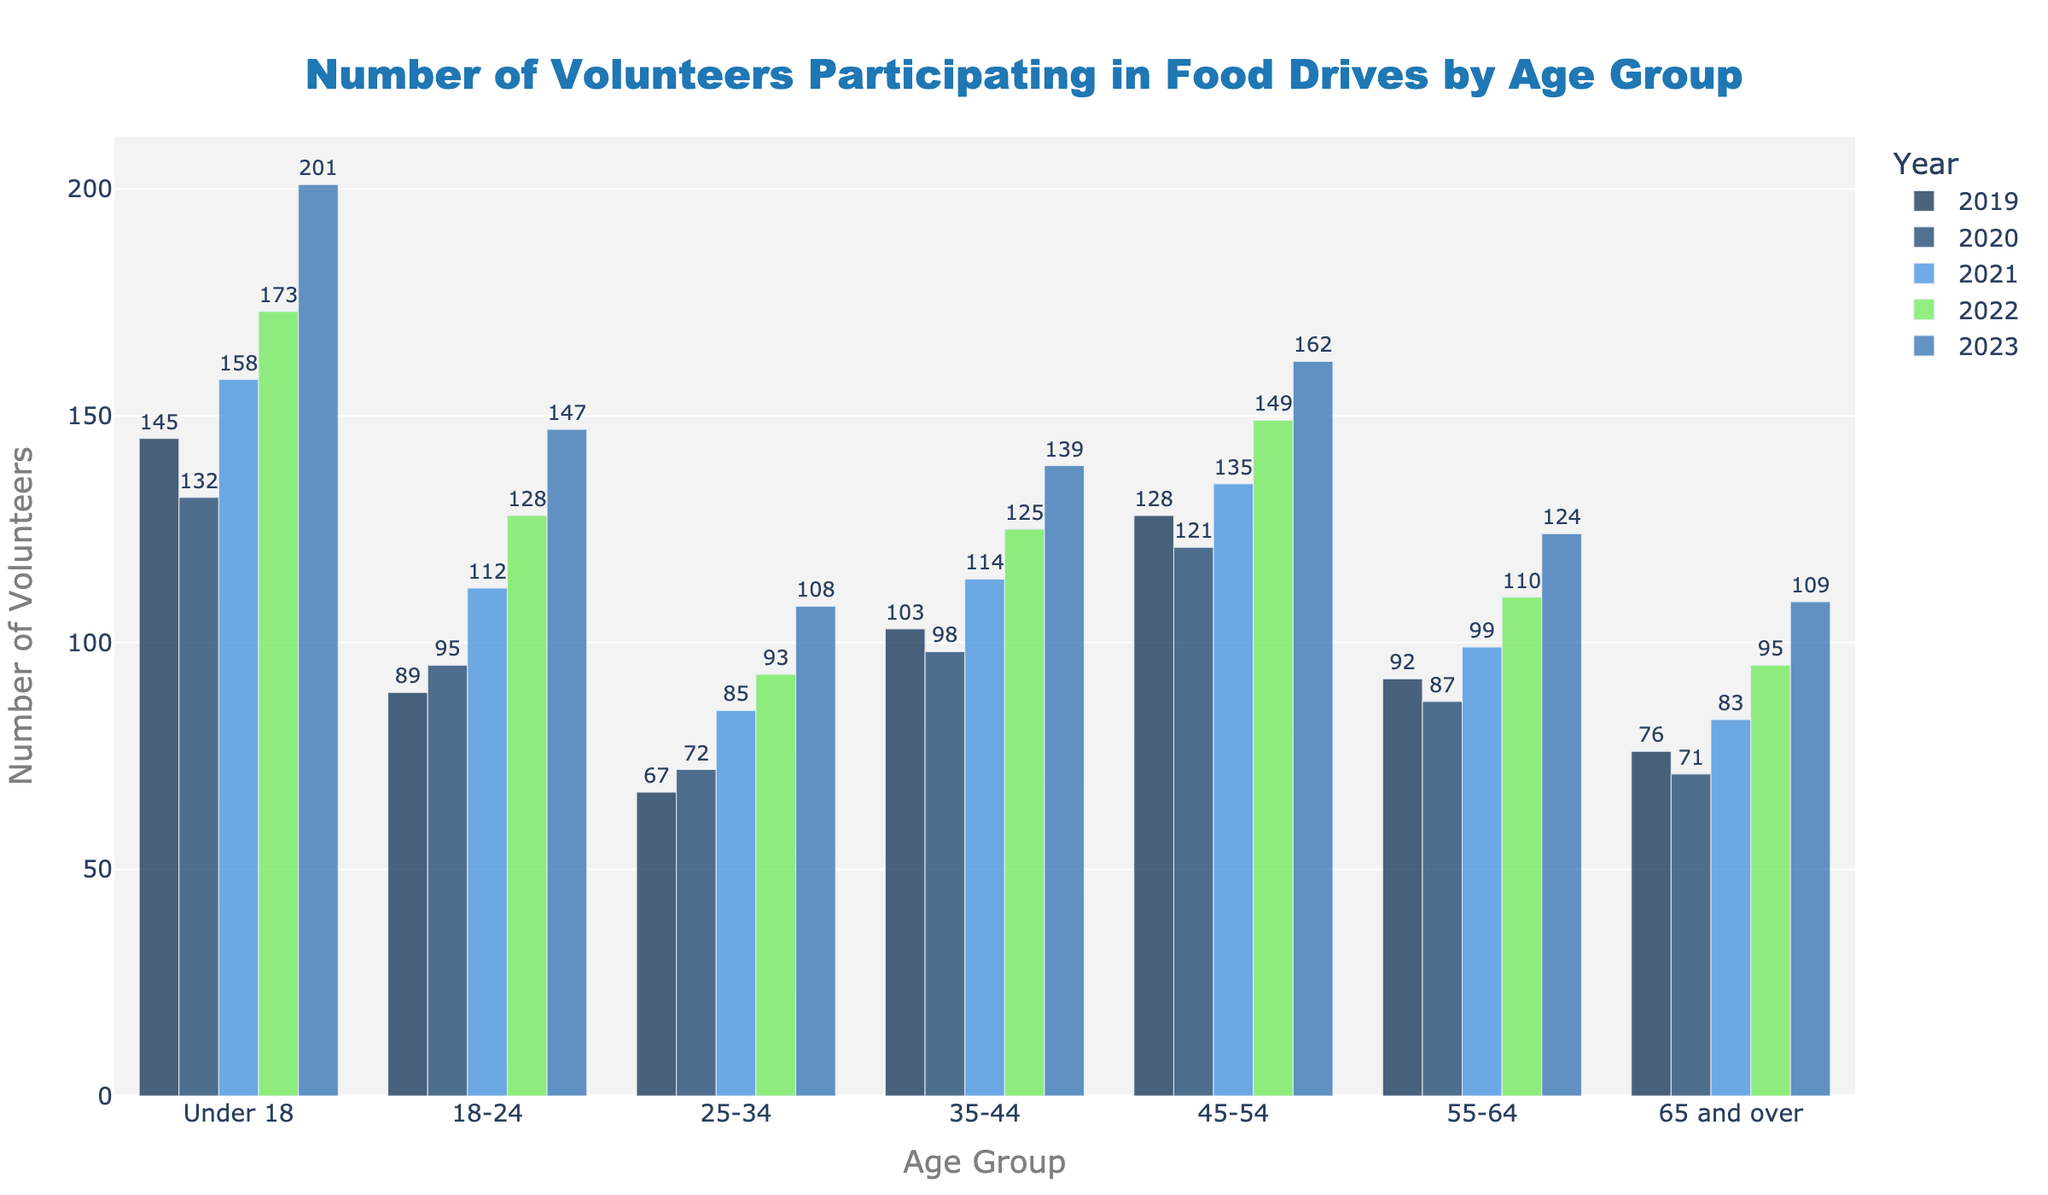Which age group had the highest number of volunteers in 2023? By looking at the bars representing 2023, we can see that the "Under 18" age group has the tallest bar, indicating the highest number of volunteers.
Answer: Under 18 What is the difference in the number of volunteers between the age groups "Under 18" and "65 and over" in 2023? In 2023, the "Under 18" group had 201 volunteers and the "65 and over" group had 109 volunteers. The difference is 201 - 109 = 92.
Answer: 92 How did the number of volunteers in the "18-24" age group change from 2019 to 2023? In 2019, there were 89 volunteers in the "18-24" age group, and in 2023, there were 147 volunteers. The change is 147 - 89 = 58.
Answer: Increased by 58 Which year had the smallest number of volunteers in the "55-64" age group? Observing the bars for the "55-64" age group, the shortest bar represents 2020 with 87 volunteers.
Answer: 2020 On average, how many volunteers participated in the food drive per year in the "35-44" age group? The numbers of volunteers for the "35-44" age group over the five years are 103, 98, 114, 125, and 139. The average is (103 + 98 + 114 + 125 + 139) / 5 = 115.8.
Answer: 115.8 Compare the number of volunteers in the "45-54" age group in 2020 and 2021. What is the percentage increase? In 2020, there were 121 volunteers, and in 2021 there were 135 volunteers in the "45-54" age group. The percentage increase is ((135 - 121) / 121) * 100 = 11.57%.
Answer: 11.57% In which year did the "65 and over" age group have a higher number of volunteers compared to the "25-34" age group? Looking at the bars for "65 and over" and "25-34", in 2019 and 2020, "65 and over" had 76 and 71 volunteers respectively, which is higher than "25-34" which had 67 and 72 volunteers respectively.
Answer: 2019 and 2020 